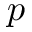<formula> <loc_0><loc_0><loc_500><loc_500>p</formula> 